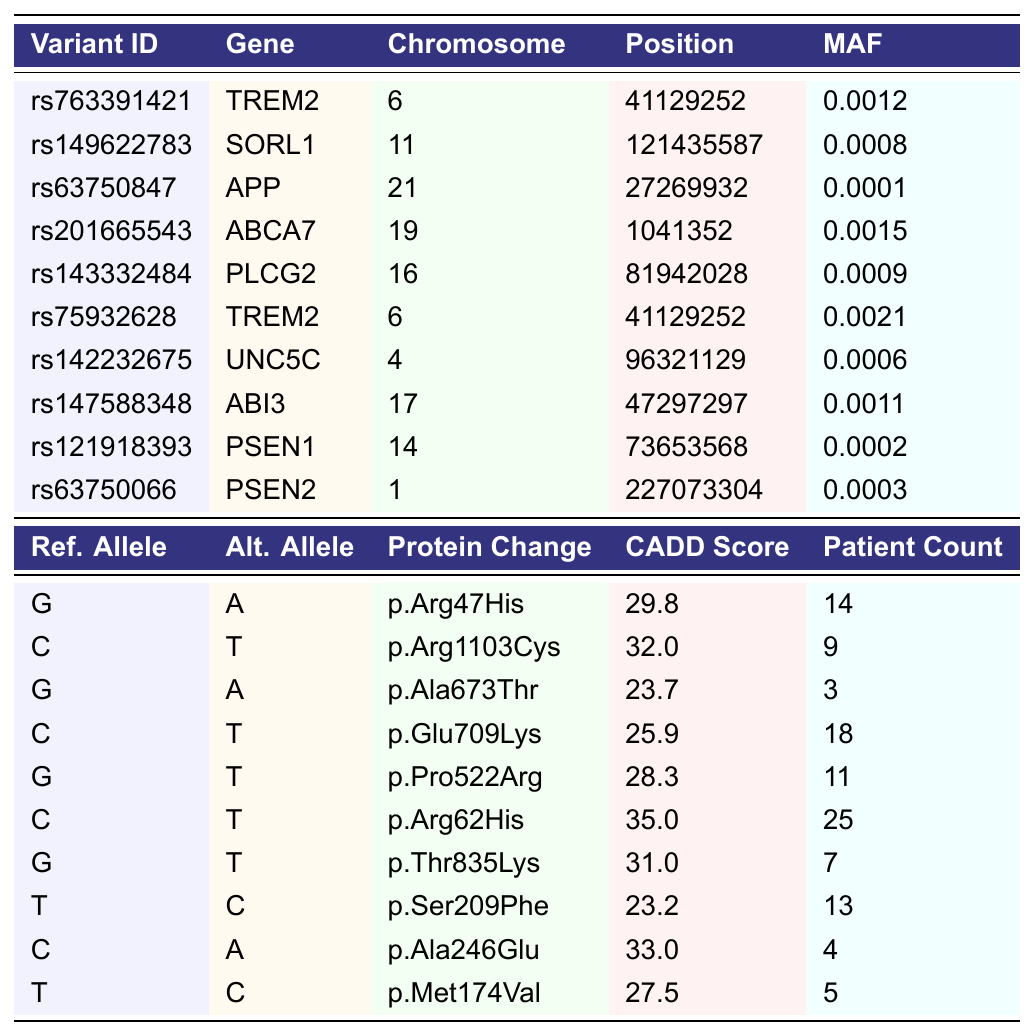What is the variant ID of the gene TREM2? The table lists the gene TREM2 and its corresponding variant IDs. There are two entries for TREM2: rs763391421 and rs75932628.
Answer: rs763391421, rs75932628 Which gene has the highest patient count and what is that count? By scanning the patient count column, the maximum value is found next to the variant ID rs75932628 which belongs to TREM2. The count is 25.
Answer: TREM2, 25 What is the minor allele frequency (MAF) range for the genetic variants listed? The MAF values from the table range from 0.0001 to 0.0021. The minimum MAF is 0.0001 for APP and the maximum is 0.0021 for TREM2 (variant rs75932628).
Answer: 0.0001 to 0.0021 How many variants have a CADD score greater than 30? Checking the CADD scores in the table, the variants with scores greater than 30 are rs149622783 (32.0), rs75932628 (35.0), and rs121918393 (33.0). That results in three variants.
Answer: 3 Which gene has the lowest CADD score and what is that score? The lowest CADD score in the table is 23.2, which corresponds to the variant rs147588348 in the gene ABI3.
Answer: ABI3, 23.2 Is there any variant with a MAF below 0.001? Scanning the MAF values, both rs63750847 and rs121918393 show MAF values of 0.0001 and 0.0002 respectively, indicating that there are variants with MAF below 0.001.
Answer: Yes How many more patients have the variant with the highest patient count compared to the one with the lowest? The highest patient count is 25 for TREM2 (rs75932628) and the lowest is 3 for APP (rs63750847). The difference is 25 - 3 = 22.
Answer: 22 What percentage of variants are missense mutations based on the given data? All the variants listed in the table are missense (10 out of 10), leading to 100% being missense mutations.
Answer: 100% Which chromosome has the most associated genes in this dataset? The data includes variants from chromosomes 1, 4, 6, 11, 14, 16, 17, 19, and 21. The maximum number of associated genes is for chromosome 6 with two genes (TREM2).
Answer: 6 If we consider the MAF values only, calculate the average MAF for the listed variants. The MAF values are: 0.0012, 0.0008, 0.0001, 0.0015, 0.0009, 0.0021, 0.0006, 0.0011, 0.0002, 0.0003. Summing these yields 0.0087. Dividing by 10 (the number of variants) gives an average MAF of 0.00087.
Answer: 0.00087 